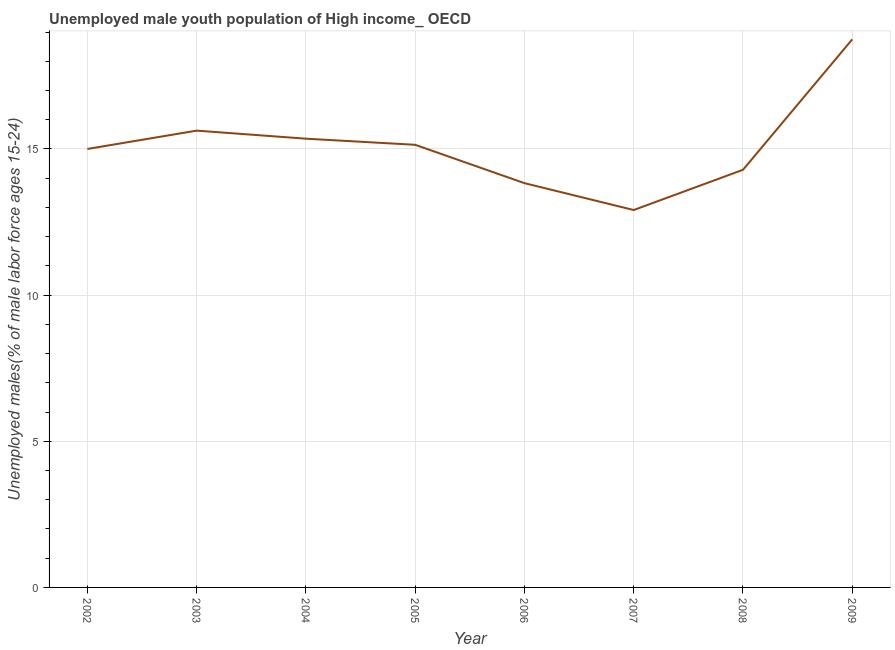What is the unemployed male youth in 2006?
Provide a succinct answer. 13.83. Across all years, what is the maximum unemployed male youth?
Ensure brevity in your answer.  18.75. Across all years, what is the minimum unemployed male youth?
Your answer should be compact. 12.91. In which year was the unemployed male youth maximum?
Keep it short and to the point. 2009. In which year was the unemployed male youth minimum?
Provide a short and direct response. 2007. What is the sum of the unemployed male youth?
Provide a short and direct response. 120.89. What is the difference between the unemployed male youth in 2004 and 2005?
Give a very brief answer. 0.21. What is the average unemployed male youth per year?
Give a very brief answer. 15.11. What is the median unemployed male youth?
Provide a short and direct response. 15.07. In how many years, is the unemployed male youth greater than 15 %?
Offer a terse response. 4. What is the ratio of the unemployed male youth in 2005 to that in 2006?
Give a very brief answer. 1.09. What is the difference between the highest and the second highest unemployed male youth?
Your answer should be very brief. 3.12. Is the sum of the unemployed male youth in 2002 and 2007 greater than the maximum unemployed male youth across all years?
Your answer should be compact. Yes. What is the difference between the highest and the lowest unemployed male youth?
Offer a terse response. 5.84. Does the unemployed male youth monotonically increase over the years?
Give a very brief answer. No. How many lines are there?
Provide a succinct answer. 1. How many years are there in the graph?
Provide a succinct answer. 8. What is the difference between two consecutive major ticks on the Y-axis?
Offer a terse response. 5. Are the values on the major ticks of Y-axis written in scientific E-notation?
Your answer should be compact. No. What is the title of the graph?
Give a very brief answer. Unemployed male youth population of High income_ OECD. What is the label or title of the X-axis?
Offer a very short reply. Year. What is the label or title of the Y-axis?
Your response must be concise. Unemployed males(% of male labor force ages 15-24). What is the Unemployed males(% of male labor force ages 15-24) of 2002?
Ensure brevity in your answer.  15. What is the Unemployed males(% of male labor force ages 15-24) of 2003?
Your answer should be compact. 15.63. What is the Unemployed males(% of male labor force ages 15-24) in 2004?
Your answer should be compact. 15.35. What is the Unemployed males(% of male labor force ages 15-24) of 2005?
Provide a short and direct response. 15.14. What is the Unemployed males(% of male labor force ages 15-24) in 2006?
Ensure brevity in your answer.  13.83. What is the Unemployed males(% of male labor force ages 15-24) in 2007?
Your response must be concise. 12.91. What is the Unemployed males(% of male labor force ages 15-24) in 2008?
Keep it short and to the point. 14.29. What is the Unemployed males(% of male labor force ages 15-24) in 2009?
Make the answer very short. 18.75. What is the difference between the Unemployed males(% of male labor force ages 15-24) in 2002 and 2003?
Make the answer very short. -0.63. What is the difference between the Unemployed males(% of male labor force ages 15-24) in 2002 and 2004?
Offer a terse response. -0.35. What is the difference between the Unemployed males(% of male labor force ages 15-24) in 2002 and 2005?
Give a very brief answer. -0.14. What is the difference between the Unemployed males(% of male labor force ages 15-24) in 2002 and 2006?
Provide a short and direct response. 1.17. What is the difference between the Unemployed males(% of male labor force ages 15-24) in 2002 and 2007?
Your answer should be compact. 2.09. What is the difference between the Unemployed males(% of male labor force ages 15-24) in 2002 and 2008?
Provide a succinct answer. 0.71. What is the difference between the Unemployed males(% of male labor force ages 15-24) in 2002 and 2009?
Give a very brief answer. -3.75. What is the difference between the Unemployed males(% of male labor force ages 15-24) in 2003 and 2004?
Provide a short and direct response. 0.28. What is the difference between the Unemployed males(% of male labor force ages 15-24) in 2003 and 2005?
Keep it short and to the point. 0.48. What is the difference between the Unemployed males(% of male labor force ages 15-24) in 2003 and 2006?
Offer a very short reply. 1.8. What is the difference between the Unemployed males(% of male labor force ages 15-24) in 2003 and 2007?
Your response must be concise. 2.72. What is the difference between the Unemployed males(% of male labor force ages 15-24) in 2003 and 2008?
Give a very brief answer. 1.34. What is the difference between the Unemployed males(% of male labor force ages 15-24) in 2003 and 2009?
Provide a short and direct response. -3.12. What is the difference between the Unemployed males(% of male labor force ages 15-24) in 2004 and 2005?
Give a very brief answer. 0.21. What is the difference between the Unemployed males(% of male labor force ages 15-24) in 2004 and 2006?
Your answer should be compact. 1.52. What is the difference between the Unemployed males(% of male labor force ages 15-24) in 2004 and 2007?
Provide a succinct answer. 2.44. What is the difference between the Unemployed males(% of male labor force ages 15-24) in 2004 and 2008?
Offer a terse response. 1.06. What is the difference between the Unemployed males(% of male labor force ages 15-24) in 2004 and 2009?
Ensure brevity in your answer.  -3.4. What is the difference between the Unemployed males(% of male labor force ages 15-24) in 2005 and 2006?
Ensure brevity in your answer.  1.31. What is the difference between the Unemployed males(% of male labor force ages 15-24) in 2005 and 2007?
Offer a very short reply. 2.23. What is the difference between the Unemployed males(% of male labor force ages 15-24) in 2005 and 2008?
Make the answer very short. 0.86. What is the difference between the Unemployed males(% of male labor force ages 15-24) in 2005 and 2009?
Your answer should be compact. -3.61. What is the difference between the Unemployed males(% of male labor force ages 15-24) in 2006 and 2007?
Your answer should be compact. 0.92. What is the difference between the Unemployed males(% of male labor force ages 15-24) in 2006 and 2008?
Your response must be concise. -0.46. What is the difference between the Unemployed males(% of male labor force ages 15-24) in 2006 and 2009?
Give a very brief answer. -4.92. What is the difference between the Unemployed males(% of male labor force ages 15-24) in 2007 and 2008?
Provide a succinct answer. -1.38. What is the difference between the Unemployed males(% of male labor force ages 15-24) in 2007 and 2009?
Offer a very short reply. -5.84. What is the difference between the Unemployed males(% of male labor force ages 15-24) in 2008 and 2009?
Your answer should be compact. -4.46. What is the ratio of the Unemployed males(% of male labor force ages 15-24) in 2002 to that in 2004?
Make the answer very short. 0.98. What is the ratio of the Unemployed males(% of male labor force ages 15-24) in 2002 to that in 2005?
Provide a succinct answer. 0.99. What is the ratio of the Unemployed males(% of male labor force ages 15-24) in 2002 to that in 2006?
Give a very brief answer. 1.08. What is the ratio of the Unemployed males(% of male labor force ages 15-24) in 2002 to that in 2007?
Ensure brevity in your answer.  1.16. What is the ratio of the Unemployed males(% of male labor force ages 15-24) in 2002 to that in 2009?
Make the answer very short. 0.8. What is the ratio of the Unemployed males(% of male labor force ages 15-24) in 2003 to that in 2005?
Ensure brevity in your answer.  1.03. What is the ratio of the Unemployed males(% of male labor force ages 15-24) in 2003 to that in 2006?
Ensure brevity in your answer.  1.13. What is the ratio of the Unemployed males(% of male labor force ages 15-24) in 2003 to that in 2007?
Make the answer very short. 1.21. What is the ratio of the Unemployed males(% of male labor force ages 15-24) in 2003 to that in 2008?
Provide a succinct answer. 1.09. What is the ratio of the Unemployed males(% of male labor force ages 15-24) in 2003 to that in 2009?
Give a very brief answer. 0.83. What is the ratio of the Unemployed males(% of male labor force ages 15-24) in 2004 to that in 2005?
Offer a terse response. 1.01. What is the ratio of the Unemployed males(% of male labor force ages 15-24) in 2004 to that in 2006?
Provide a succinct answer. 1.11. What is the ratio of the Unemployed males(% of male labor force ages 15-24) in 2004 to that in 2007?
Your answer should be compact. 1.19. What is the ratio of the Unemployed males(% of male labor force ages 15-24) in 2004 to that in 2008?
Your answer should be compact. 1.07. What is the ratio of the Unemployed males(% of male labor force ages 15-24) in 2004 to that in 2009?
Your answer should be compact. 0.82. What is the ratio of the Unemployed males(% of male labor force ages 15-24) in 2005 to that in 2006?
Provide a short and direct response. 1.09. What is the ratio of the Unemployed males(% of male labor force ages 15-24) in 2005 to that in 2007?
Keep it short and to the point. 1.17. What is the ratio of the Unemployed males(% of male labor force ages 15-24) in 2005 to that in 2008?
Keep it short and to the point. 1.06. What is the ratio of the Unemployed males(% of male labor force ages 15-24) in 2005 to that in 2009?
Make the answer very short. 0.81. What is the ratio of the Unemployed males(% of male labor force ages 15-24) in 2006 to that in 2007?
Make the answer very short. 1.07. What is the ratio of the Unemployed males(% of male labor force ages 15-24) in 2006 to that in 2009?
Your response must be concise. 0.74. What is the ratio of the Unemployed males(% of male labor force ages 15-24) in 2007 to that in 2008?
Provide a succinct answer. 0.9. What is the ratio of the Unemployed males(% of male labor force ages 15-24) in 2007 to that in 2009?
Keep it short and to the point. 0.69. What is the ratio of the Unemployed males(% of male labor force ages 15-24) in 2008 to that in 2009?
Give a very brief answer. 0.76. 